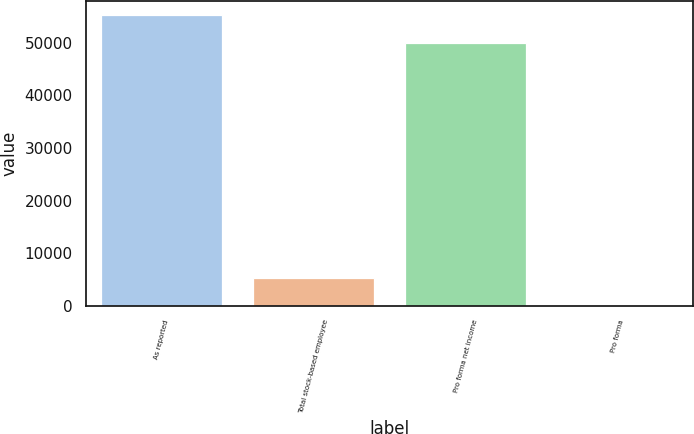<chart> <loc_0><loc_0><loc_500><loc_500><bar_chart><fcel>As reported<fcel>Total stock-based employee<fcel>Pro forma net income<fcel>Pro forma<nl><fcel>55149.9<fcel>5331.22<fcel>49820<fcel>1.36<nl></chart> 